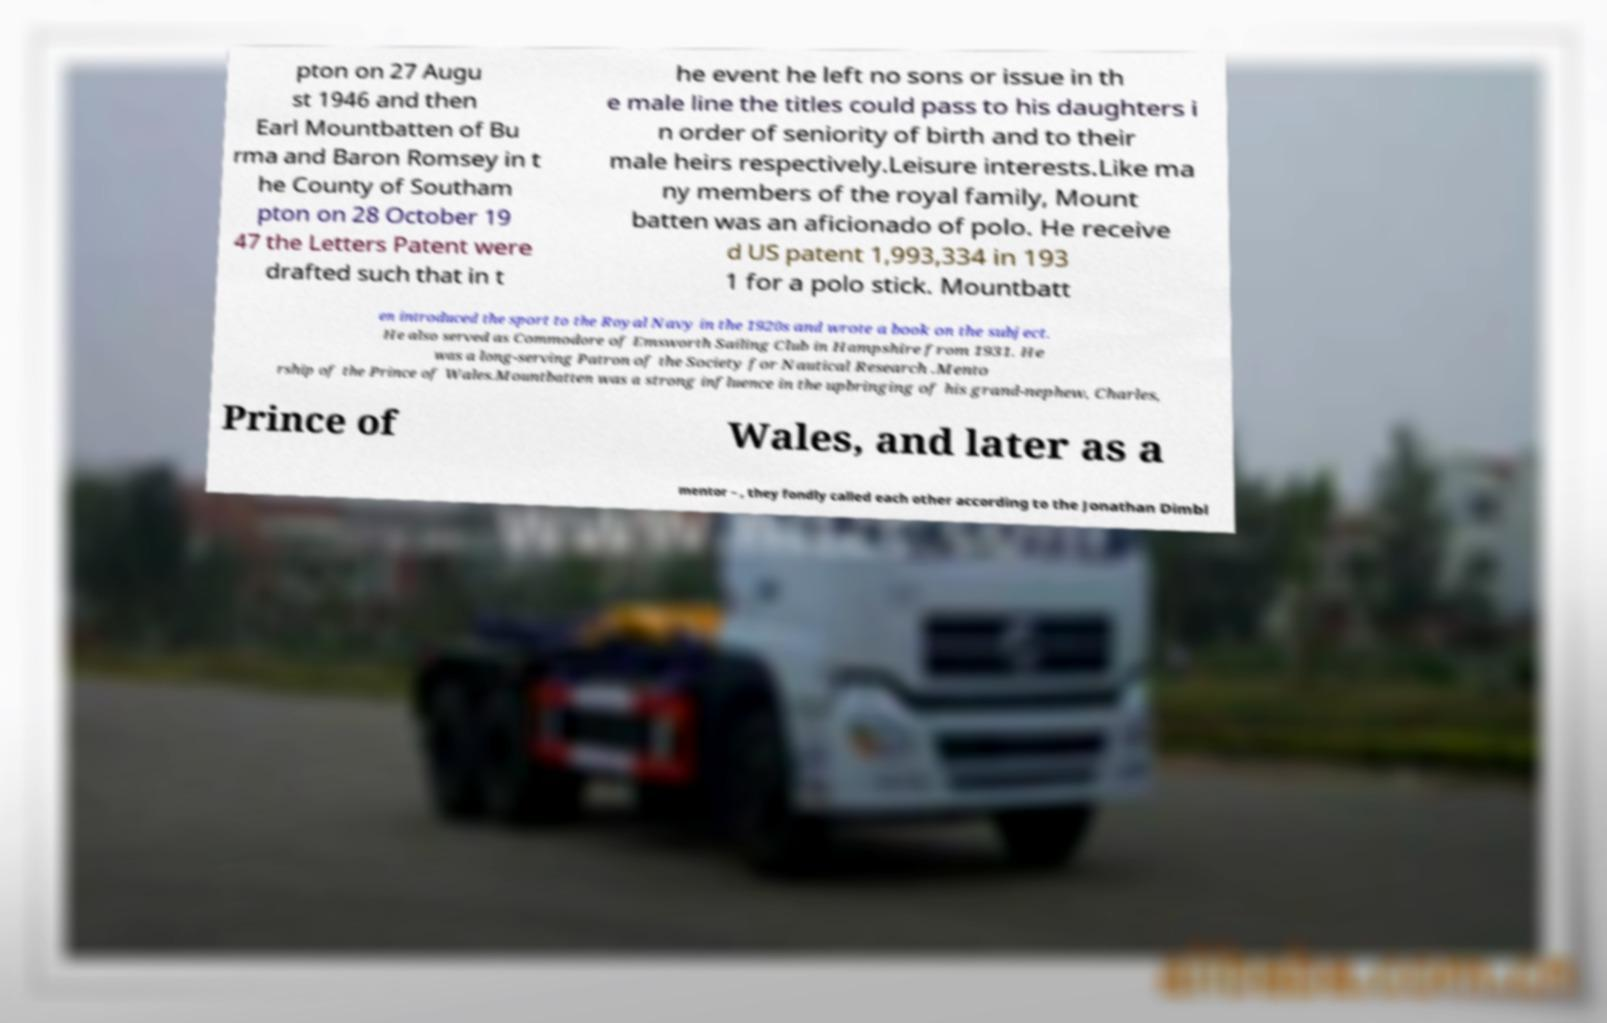What messages or text are displayed in this image? I need them in a readable, typed format. pton on 27 Augu st 1946 and then Earl Mountbatten of Bu rma and Baron Romsey in t he County of Southam pton on 28 October 19 47 the Letters Patent were drafted such that in t he event he left no sons or issue in th e male line the titles could pass to his daughters i n order of seniority of birth and to their male heirs respectively.Leisure interests.Like ma ny members of the royal family, Mount batten was an aficionado of polo. He receive d US patent 1,993,334 in 193 1 for a polo stick. Mountbatt en introduced the sport to the Royal Navy in the 1920s and wrote a book on the subject. He also served as Commodore of Emsworth Sailing Club in Hampshire from 1931. He was a long-serving Patron of the Society for Nautical Research .Mento rship of the Prince of Wales.Mountbatten was a strong influence in the upbringing of his grand-nephew, Charles, Prince of Wales, and later as a mentor – , they fondly called each other according to the Jonathan Dimbl 